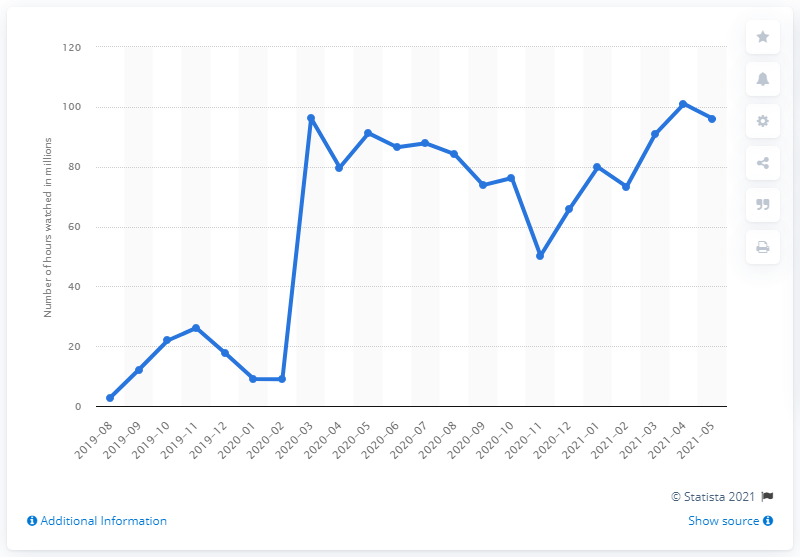Identify some key points in this picture. During the month of May 2021, a total of 96.1 hours were devoted to playing Call of Duty: Warzone. 